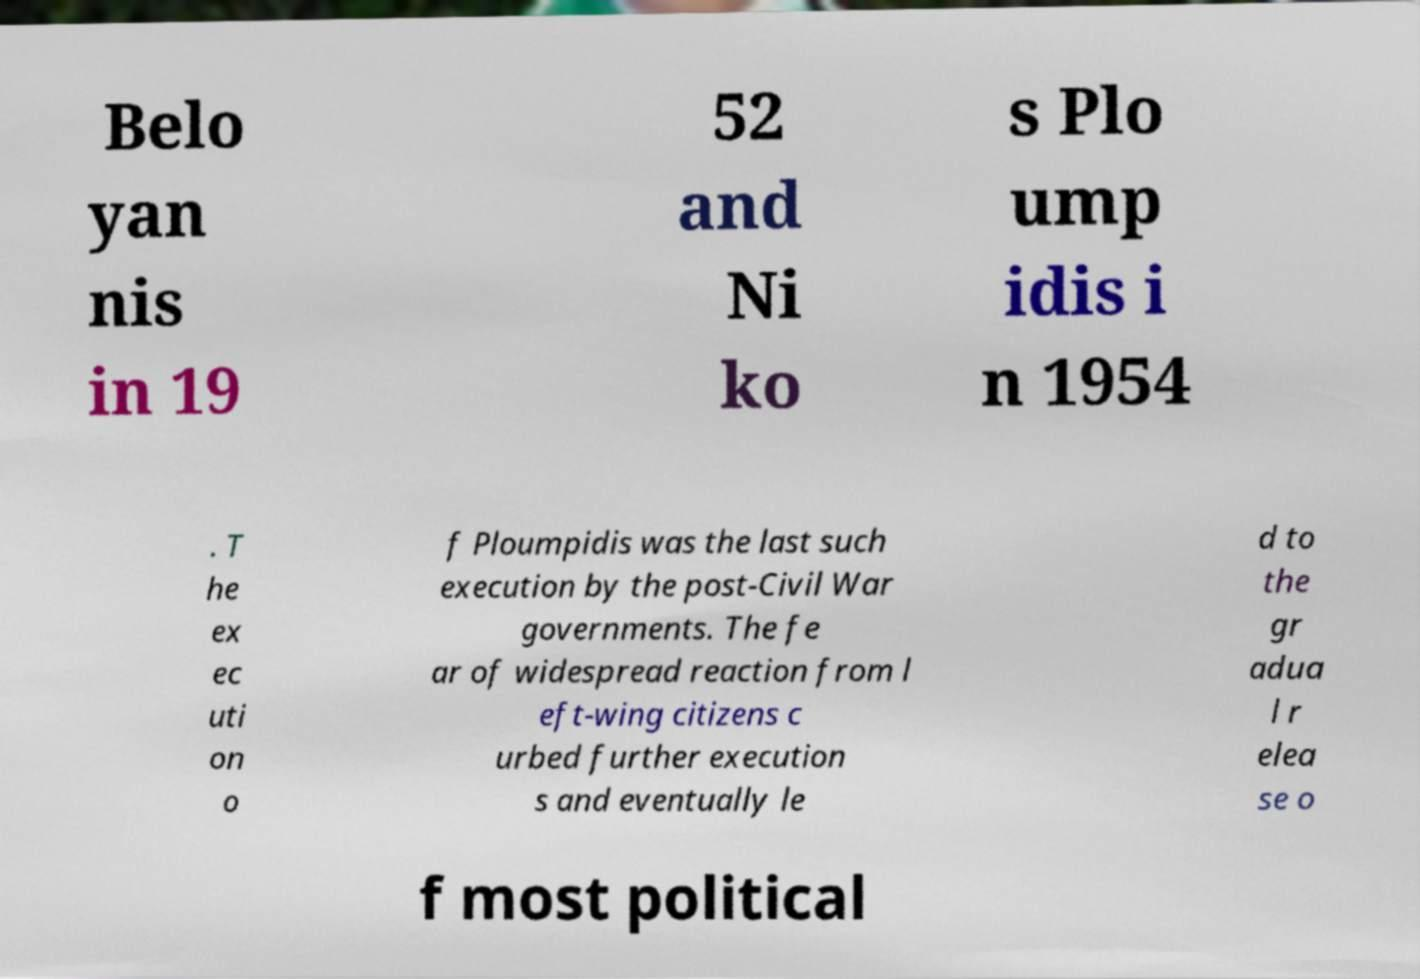Can you accurately transcribe the text from the provided image for me? Belo yan nis in 19 52 and Ni ko s Plo ump idis i n 1954 . T he ex ec uti on o f Ploumpidis was the last such execution by the post-Civil War governments. The fe ar of widespread reaction from l eft-wing citizens c urbed further execution s and eventually le d to the gr adua l r elea se o f most political 